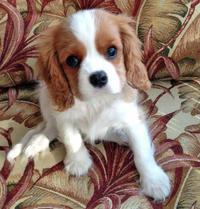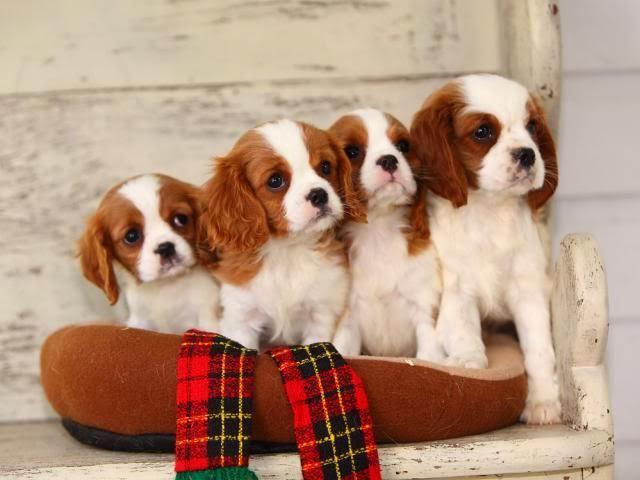The first image is the image on the left, the second image is the image on the right. Considering the images on both sides, is "One of the images contains exactly two puppies." valid? Answer yes or no. No. 